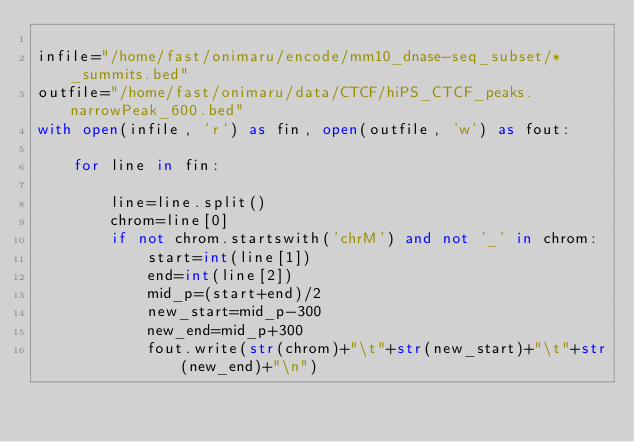Convert code to text. <code><loc_0><loc_0><loc_500><loc_500><_Python_>
infile="/home/fast/onimaru/encode/mm10_dnase-seq_subset/*_summits.bed"
outfile="/home/fast/onimaru/data/CTCF/hiPS_CTCF_peaks.narrowPeak_600.bed"
with open(infile, 'r') as fin, open(outfile, 'w') as fout:
    
    for line in fin:
        
        line=line.split()
        chrom=line[0]
        if not chrom.startswith('chrM') and not '_' in chrom:
            start=int(line[1])
            end=int(line[2])
            mid_p=(start+end)/2
            new_start=mid_p-300
            new_end=mid_p+300
            fout.write(str(chrom)+"\t"+str(new_start)+"\t"+str(new_end)+"\n")
</code> 